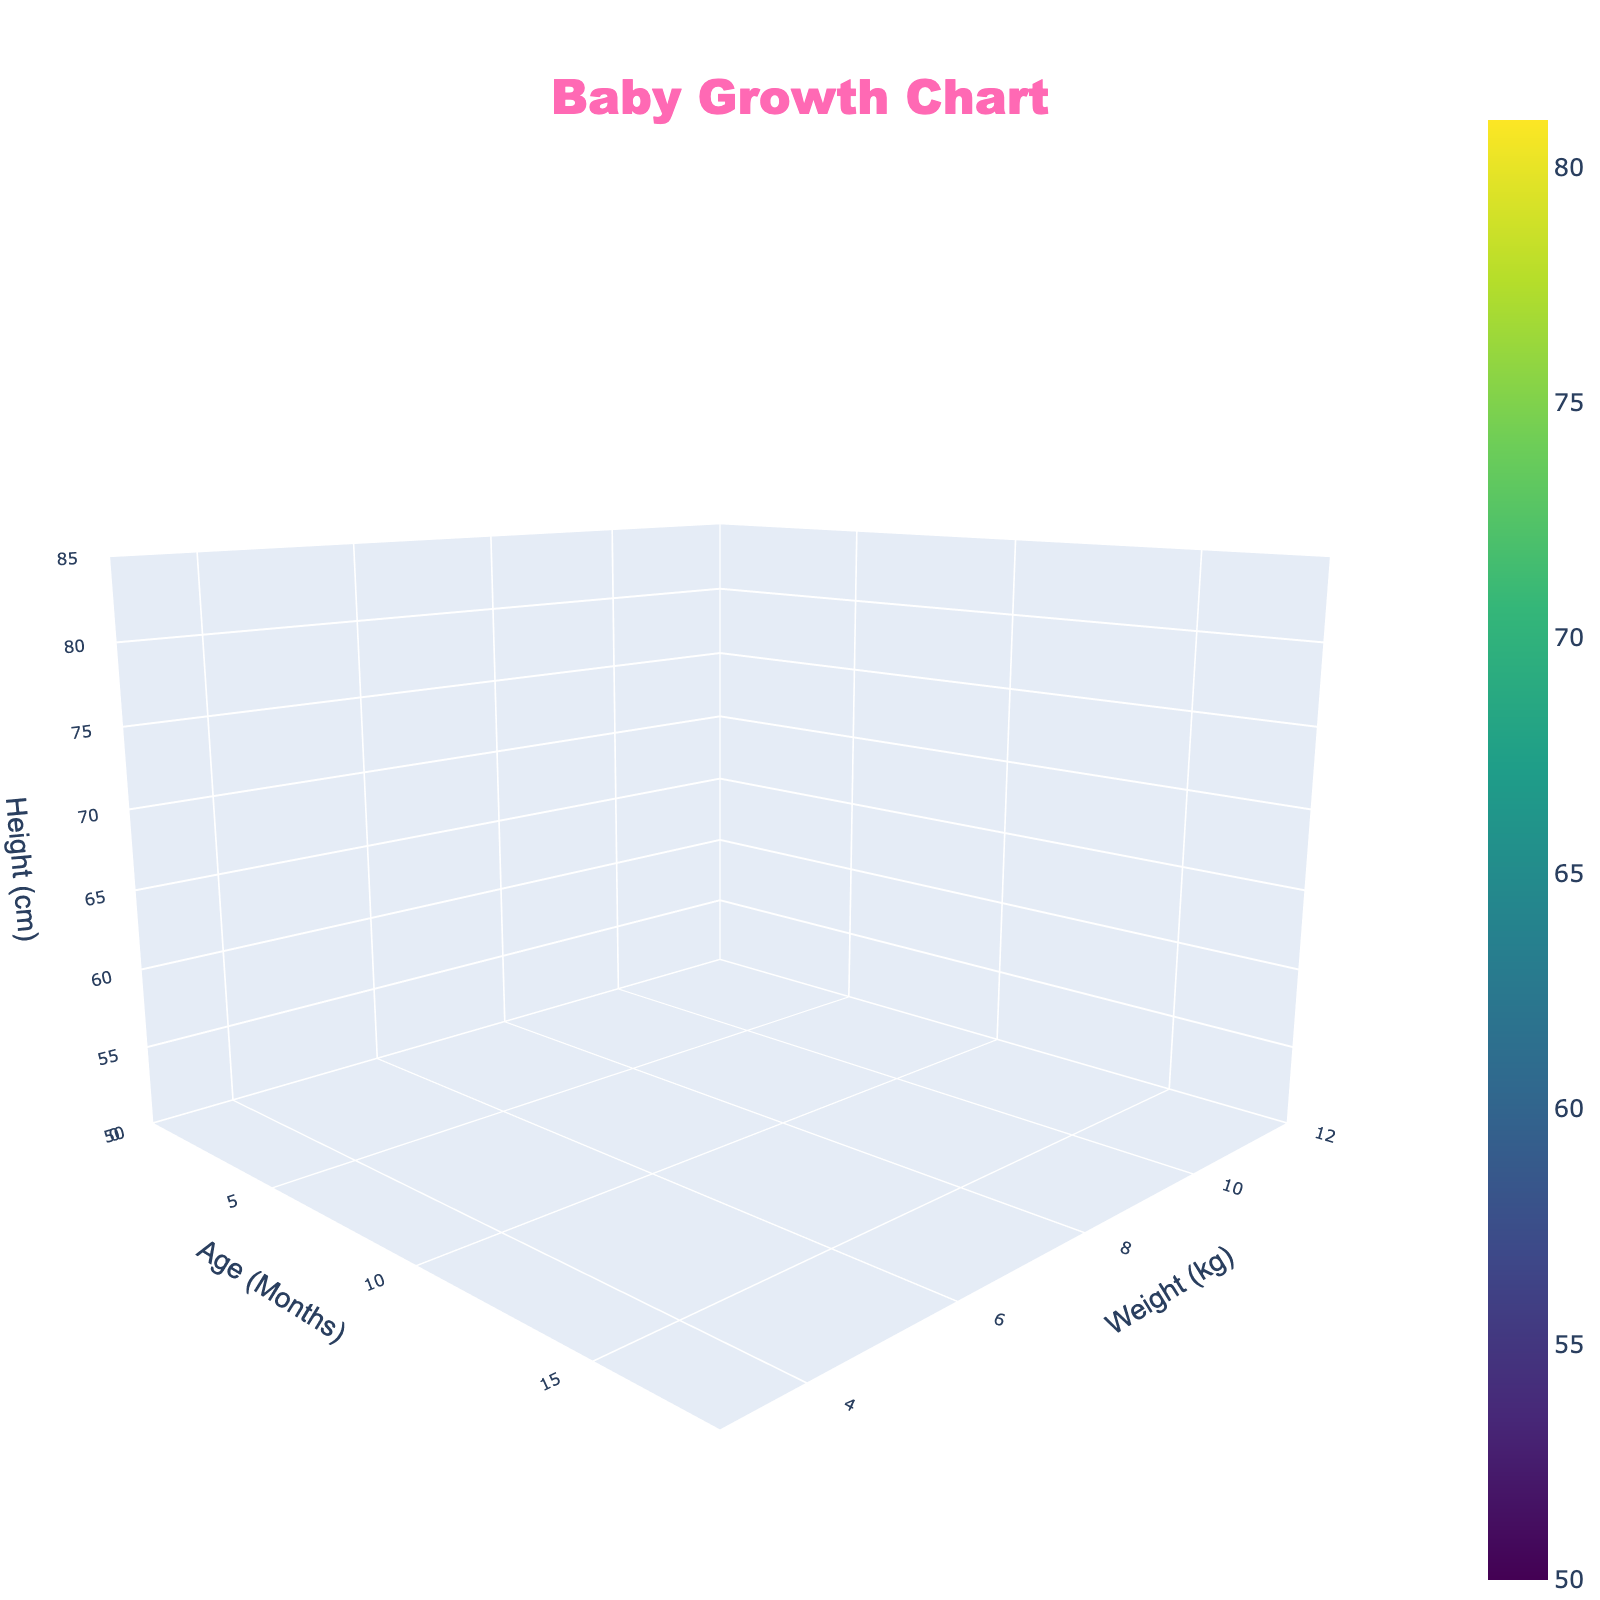What's the title of the figure? The title of the figure is displayed at the top of the plot. It reads "Baby Growth Chart".
Answer: Baby Growth Chart What information is represented on the x-axis? The x-axis represents the age of the infants in months, ranging from 0 to 18 months.
Answer: Age (Months) How does the height of the infants change as the weight increases around the 12-month mark? To observe this, look at the region of the surface plot around the age of 12 months. As weight increases, the z-axis (height) values increase, indicating that height generally increases with weight.
Answer: Height increases with weight Which infant's weight shows the highest height and at what age? Locate the highest point on the surface plot based on the z-axis (height) value. The highest point is where the surface reaches 81 cm in height at 18 months and 11.1 kg weight.
Answer: 18 months, 11.1 kg What color is most visible where the infant's height is the lowest? Check the lower regions of the surface plot on the z-axis (height) scale. The color used is part of the Viridis colorscale, and the lowest height regions will likely be of a dark blue hue.
Answer: Dark blue How does the plot show the relationship between age and head circumference? The surface plot does not directly display head circumference on any axis. The plot only shows the relationship between age, weight, and height.
Answer: The plot does not show head circumference What is the height of an infant at 6 months with a weight of 7.5 kg? Locate the point on the surface plot where the x-axis (age) is 6 months and the y-axis (weight) is 7.5 kg. The corresponding z-axis value gives the height, which is 67 cm.
Answer: 67 cm Which axis shows the biggest range of values? Compare the ranges: x-axis (0-18), y-axis (3.5-11.1), and z-axis (50-81). The z-axis has the largest range from 50 to 81 cm.
Answer: The z-axis Comparing 0 months and 9 months, by how many kg do infants' weight increases? At 0 months, the weight is 3.5 kg, and at 9 months, it is 8.8 kg. The weight increases by 8.8 - 3.5 = 5.3 kg.
Answer: 5.3 kg What is the pattern of weight gain in the first 3 months? Check the weight values at 0, 1, 2, and 3 months on the y-axis. The weights are 3.5 kg, 4.2 kg, 5.0 kg, and 5.7 kg respectively, showing a steady increase over the first 3 months.
Answer: Steady increase 